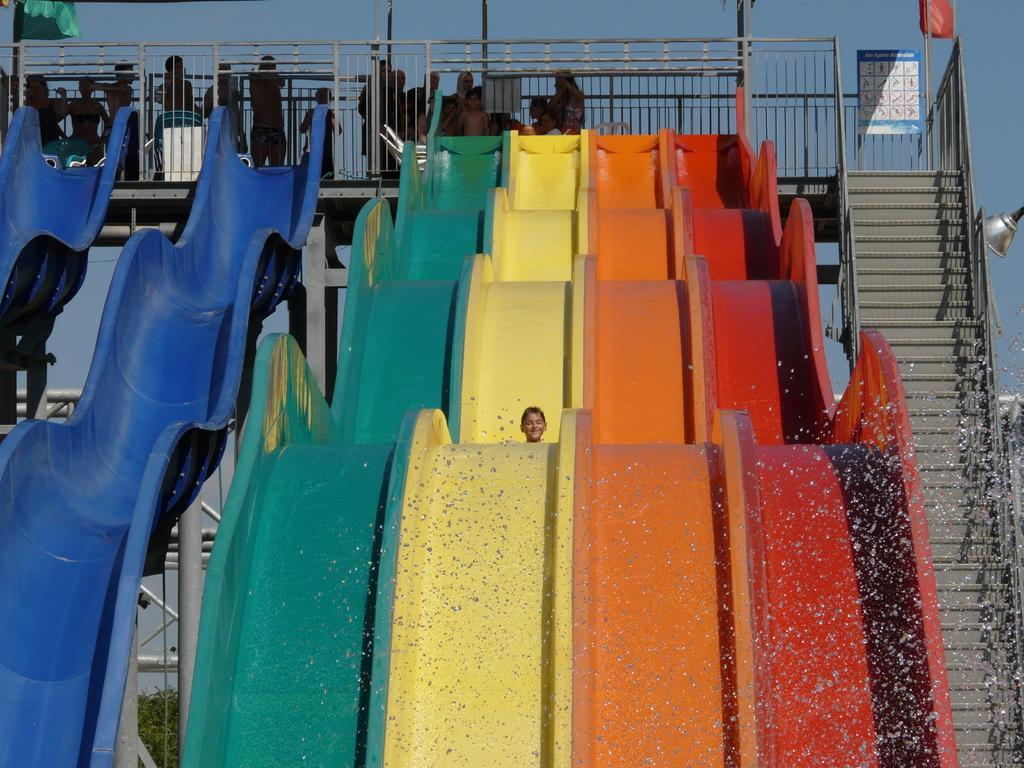Can you describe this image briefly? In the center of the image we can see water slide. On the right side of the image we can see stairs, lamp. At the top of the image we can see bridge, some persons, poles, tent. At the top of the image there is a sky. At the bottom of the image we can see some trees. 